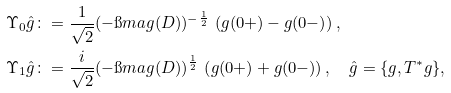Convert formula to latex. <formula><loc_0><loc_0><loc_500><loc_500>\Upsilon _ { 0 } \hat { g } & \colon = \frac { 1 } { \sqrt { 2 } } ( - \i m a g ( D ) ) ^ { - \frac { 1 } { 2 } } \, \left ( g ( 0 + ) - g ( 0 - ) \right ) , \\ \Upsilon _ { 1 } \hat { g } & \colon = \frac { i } { \sqrt { 2 } } ( - \i m a g ( D ) ) ^ { \frac { 1 } { 2 } } \, \left ( g ( 0 + ) + g ( 0 - ) \right ) , \quad \hat { g } = \{ g , T ^ { * } g \} ,</formula> 